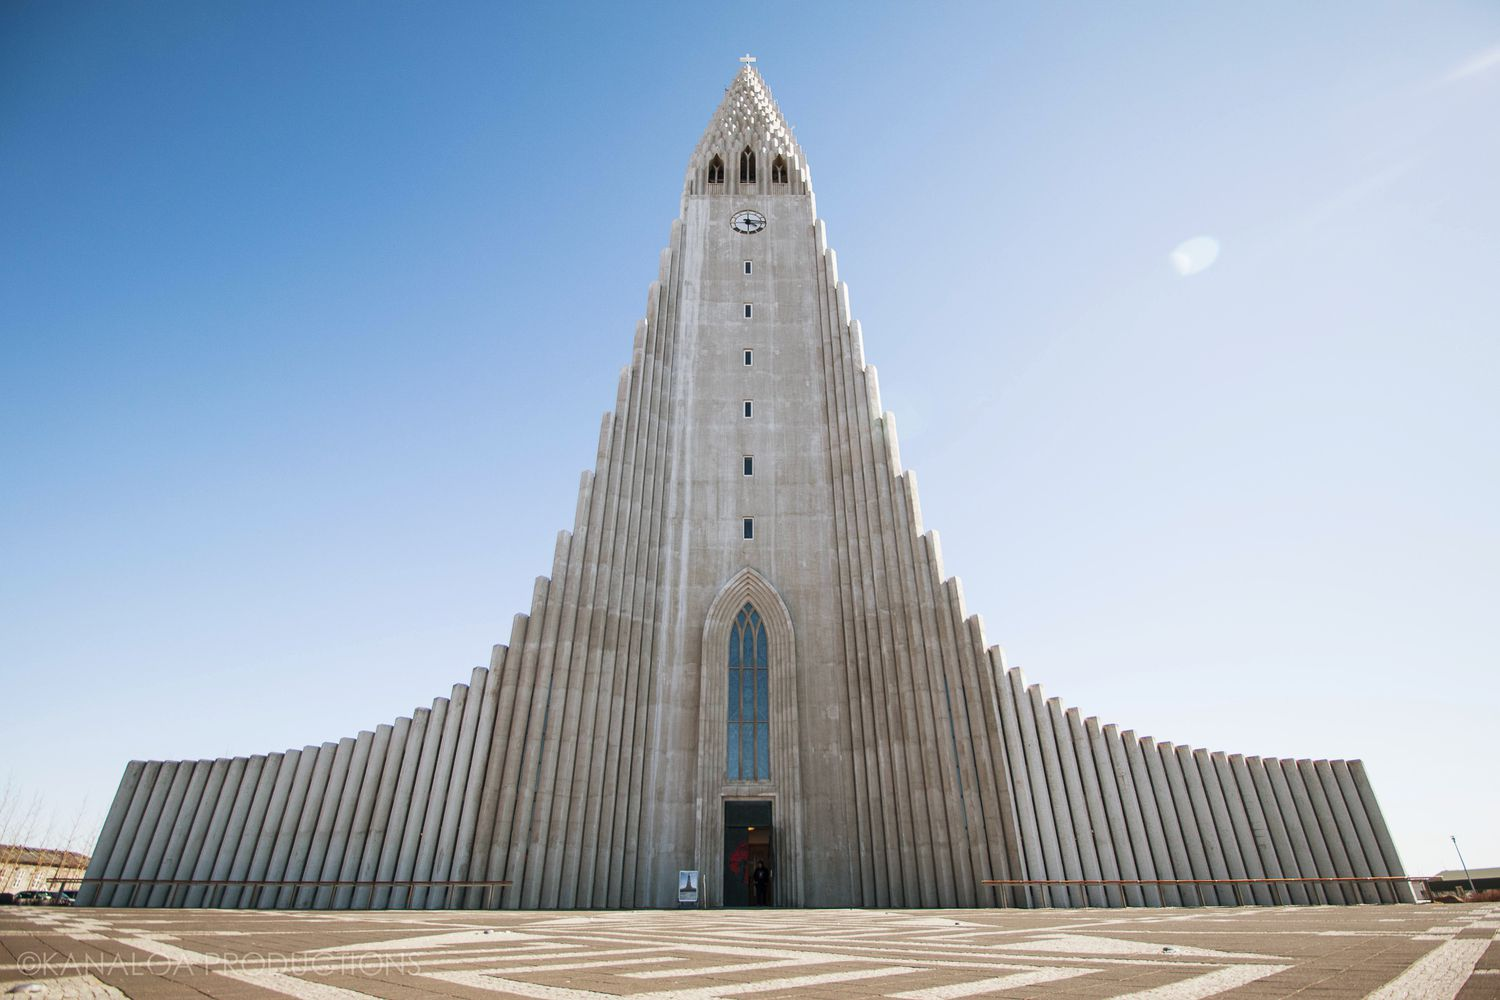How does Hallgrímskirkja influence or reflect Icelandic culture? Hallgrímskirkja reflects Icelandic culture through its dedication to minimalism and nature-inspired designs, key tenets of Icelandic art and architecture. It stands as a cultural beacon in Reykjavík, housing an iconic pipe organ and serving as both a musical venue and a place of national pride. It also embodies the spirit of Scandinavian design, which values simplicity, functionality, and connection to the natural world. 